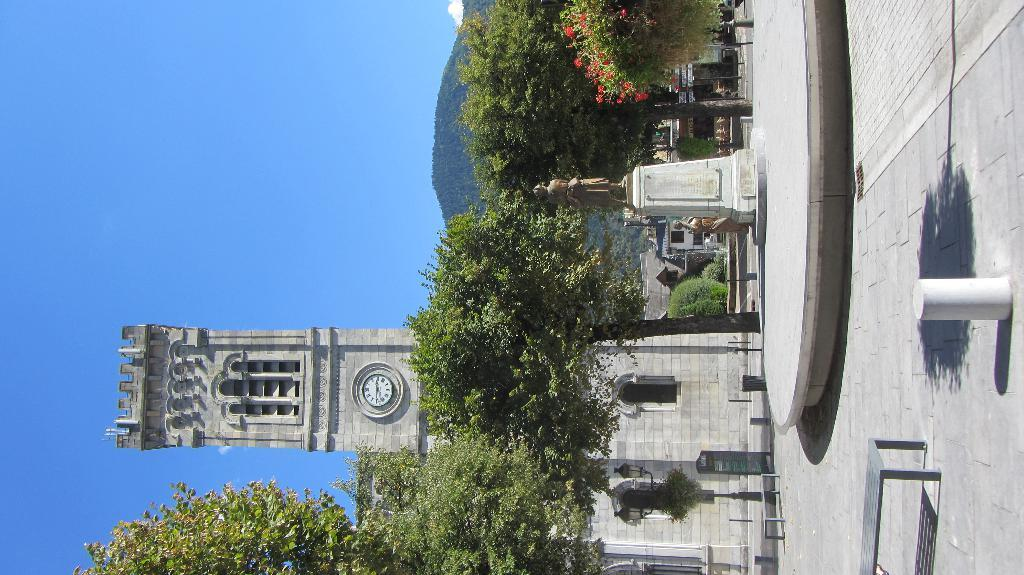What is the tall structure in the image? There is a clock tower in the image. What type of vegetation is present in the image? There are trees in the image. What is the artistic figure in the image? There is a statue in the image. What type of plants are present in the image? There are flowers in the image. What color is the sky in the image? The sky is blue in the image. Can you see the mother holding the child in the image? There is no mother or child present in the image. What type of animal can be seen hopping around the statue in the image? There are no animals, such as rabbits, present in the image. 